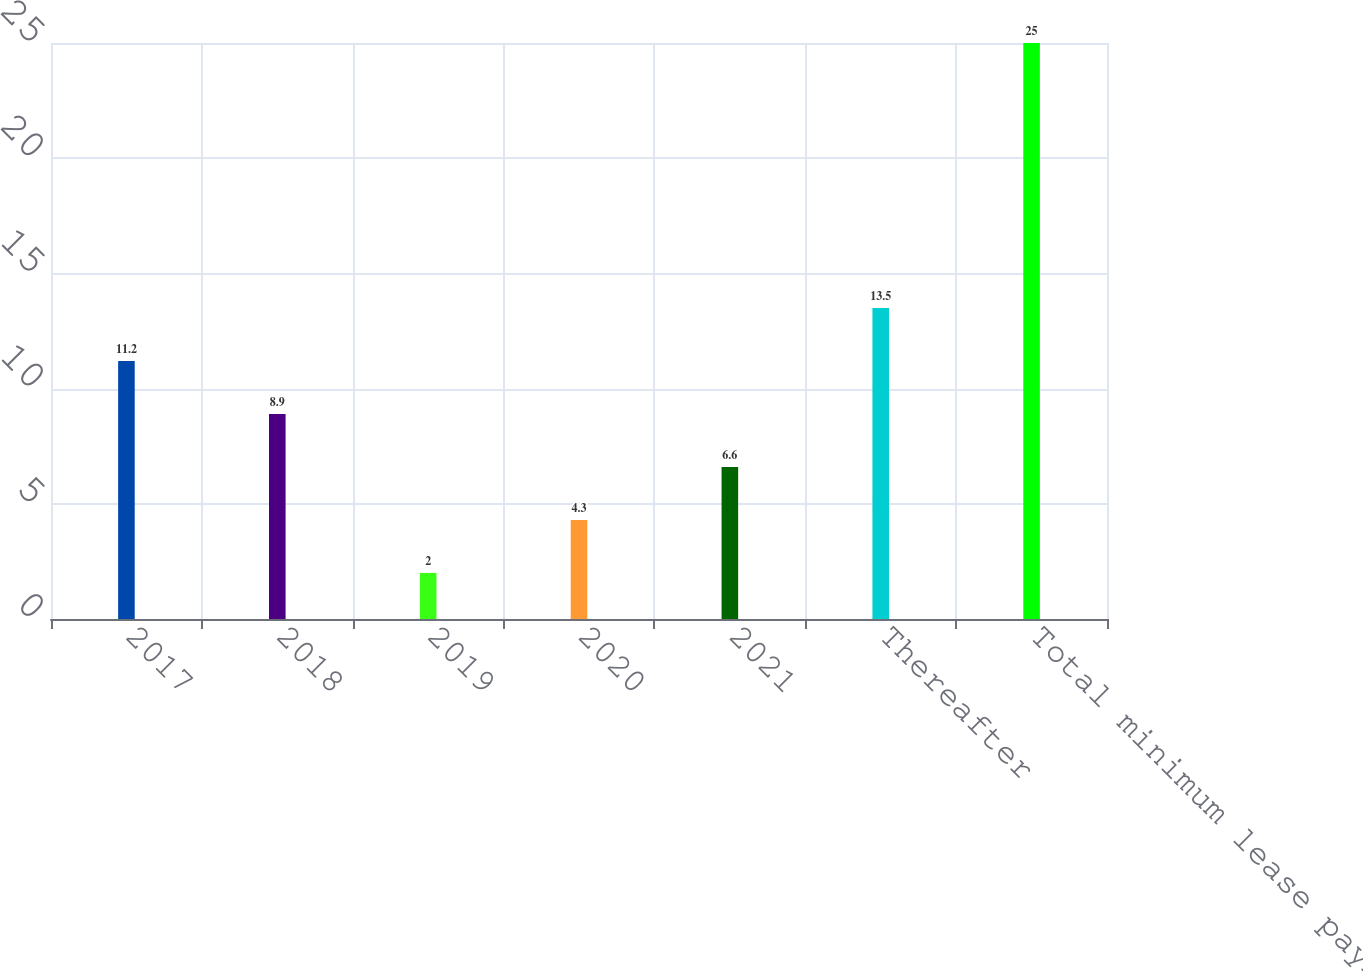<chart> <loc_0><loc_0><loc_500><loc_500><bar_chart><fcel>2017<fcel>2018<fcel>2019<fcel>2020<fcel>2021<fcel>Thereafter<fcel>Total minimum lease payments<nl><fcel>11.2<fcel>8.9<fcel>2<fcel>4.3<fcel>6.6<fcel>13.5<fcel>25<nl></chart> 